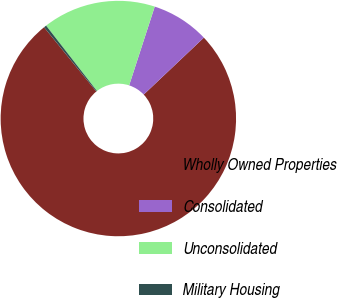Convert chart. <chart><loc_0><loc_0><loc_500><loc_500><pie_chart><fcel>Wholly Owned Properties<fcel>Consolidated<fcel>Unconsolidated<fcel>Military Housing<nl><fcel>76.19%<fcel>7.94%<fcel>15.52%<fcel>0.35%<nl></chart> 